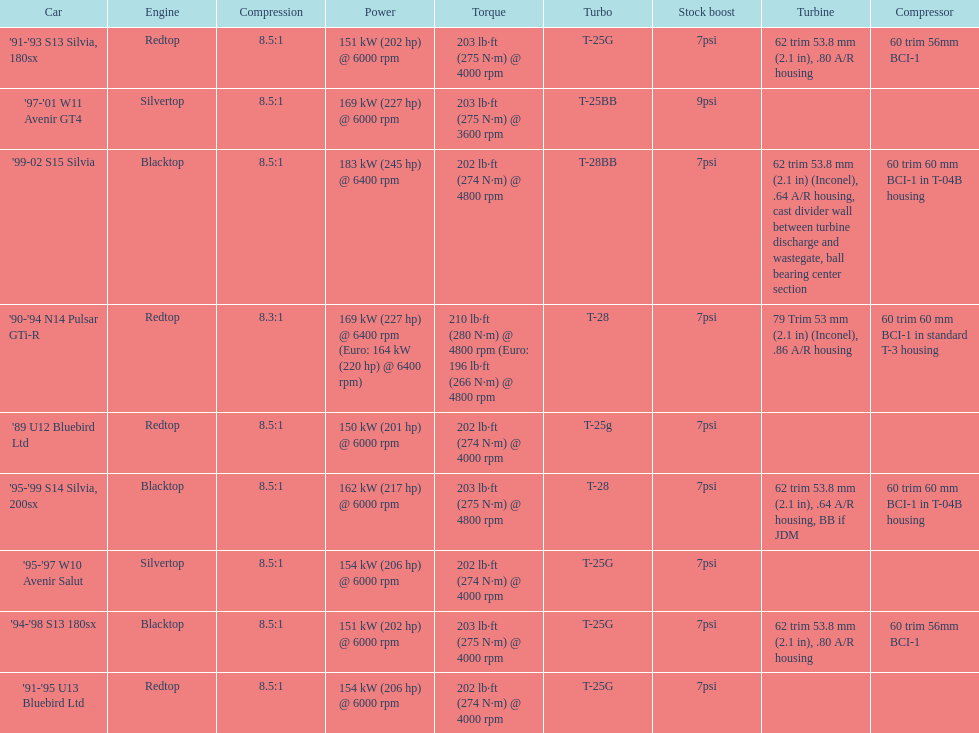How many models used the redtop engine? 4. 